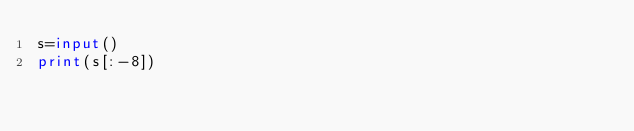<code> <loc_0><loc_0><loc_500><loc_500><_Python_>s=input()
print(s[:-8])
</code> 